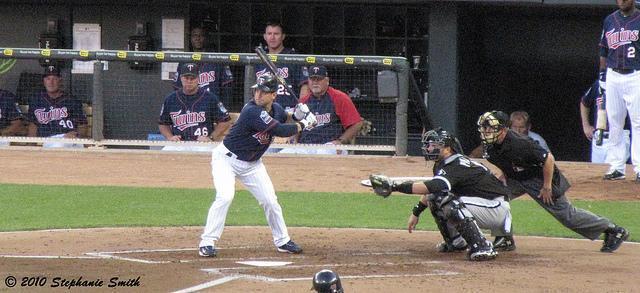What state is the batter's team located in?
Select the accurate answer and provide explanation: 'Answer: answer
Rationale: rationale.'
Options: New jersey, minnesota, new york, illinois. Answer: minnesota.
Rationale: The twins are a baseball team that play in minnesota. 